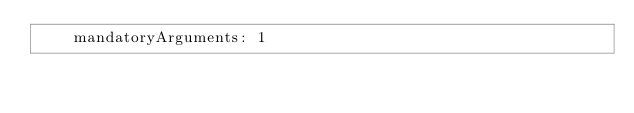Convert code to text. <code><loc_0><loc_0><loc_500><loc_500><_YAML_>    mandatoryArguments: 1
</code> 